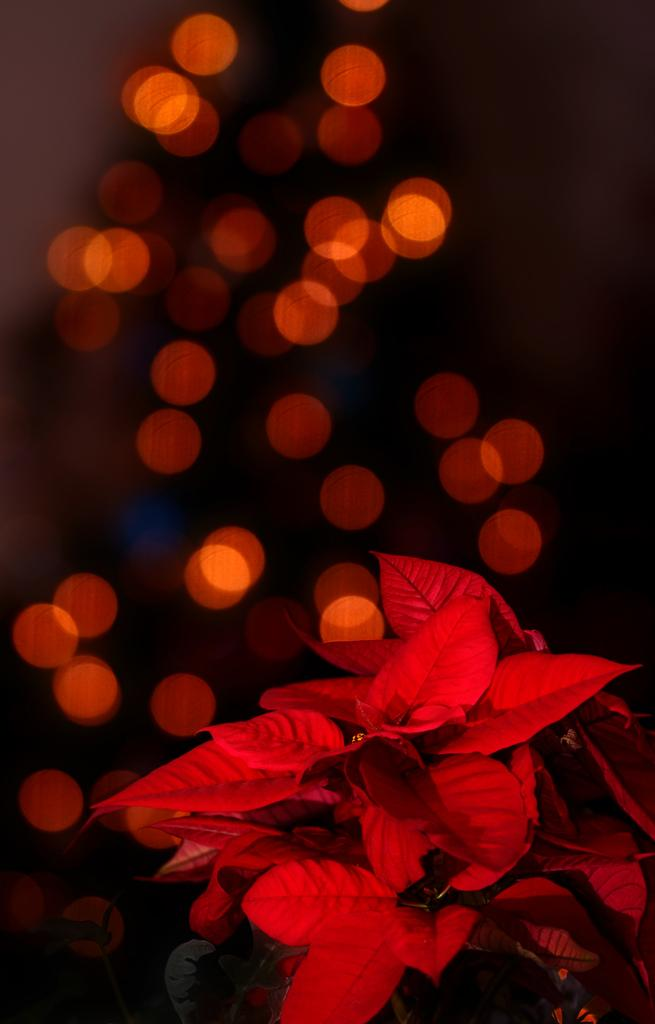What color are the leaves in the image? The leaves in the image are red. What colors are present in the background of the image? The background of the image is black and red in color. How many cattle can be seen grazing in the image? There are no cattle present in the image. What type of fuel is being used in the image? There is no fuel present in the image. 